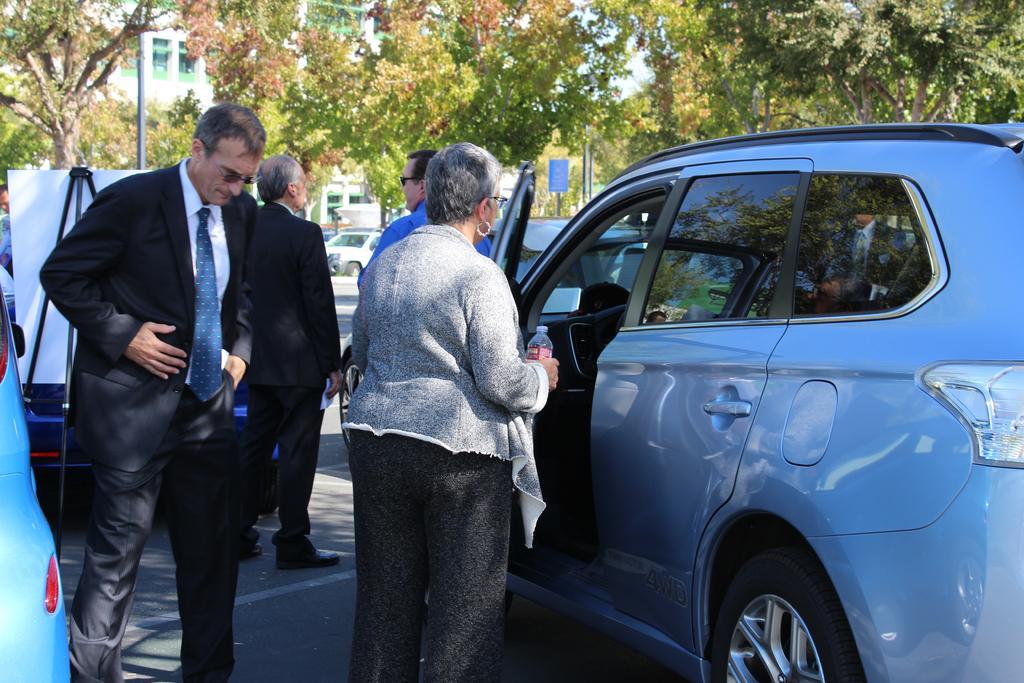How would you summarize this image in a sentence or two? In this image we can see a few people standing on the road and there are some vehicles and we can see a board. There are some trees and a building in the background. 